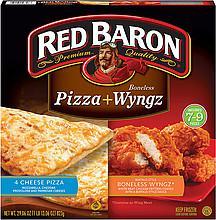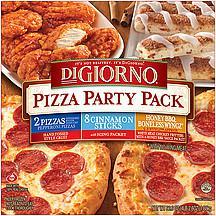The first image is the image on the left, the second image is the image on the right. Analyze the images presented: Is the assertion "An image shows a pizza box that depicts pizza on the left and coated chicken pieces on the right." valid? Answer yes or no. Yes. 